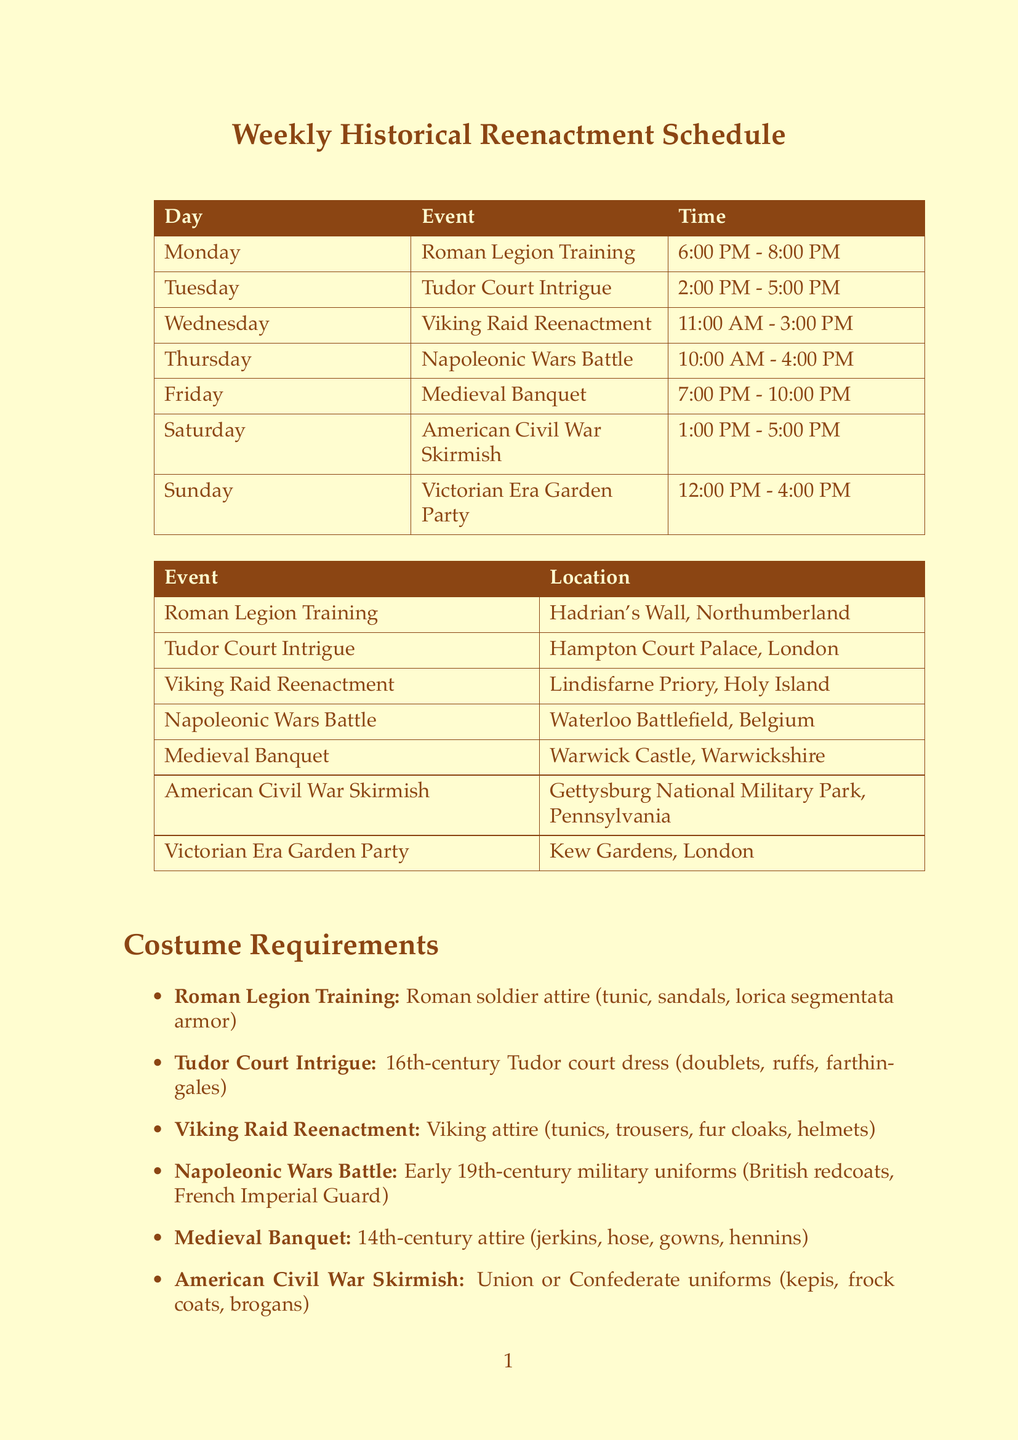What is the first event of the week? The first event listed in the schedule is "Roman Legion Training" on Monday.
Answer: Roman Legion Training What time does the Tudor Court Intrigue event start? The schedule specifies that Tudor Court Intrigue starts at 2:00 PM on Tuesday.
Answer: 2:00 PM Where is the Viking Raid Reenactment taking place? The location for the Viking Raid Reenactment is Lindisfarne Priory, Holy Island.
Answer: Lindisfarne Priory, Holy Island What is the costume requirement for the Medieval Banquet? The document states that the costume requirement for the Medieval Banquet is 14th-century attire including jerkin, hose, gowns, and hennins.
Answer: 14th-century attire (jerkins, hose, gowns, hennins) Which historical period does the American Civil War Skirmish belong to? The historical period for the American Civil War Skirmish is listed as 1861-1865.
Answer: 1861-1865 How many events are scheduled for Saturday? The schedule shows that there is one event scheduled for Saturday, which is the American Civil War Skirmish.
Answer: One event What is the organizer of the Medieval Banquet? According to the document, the organizer of the Medieval Banquet is the Marchynd Family Historical Society.
Answer: Marchynd Family Historical Society What is the duration of the Napoleonic Wars Battle event? The event lasts from 10:00 AM to 4:00 PM, making its duration six hours.
Answer: Six hours What unique attire is required for the Victorian Era Garden Party? The schedule requires late 19th-century clothing such as bustles, top hats, and parasols for this event.
Answer: Late 19th-century clothing (bustles, top hats, parasols) 